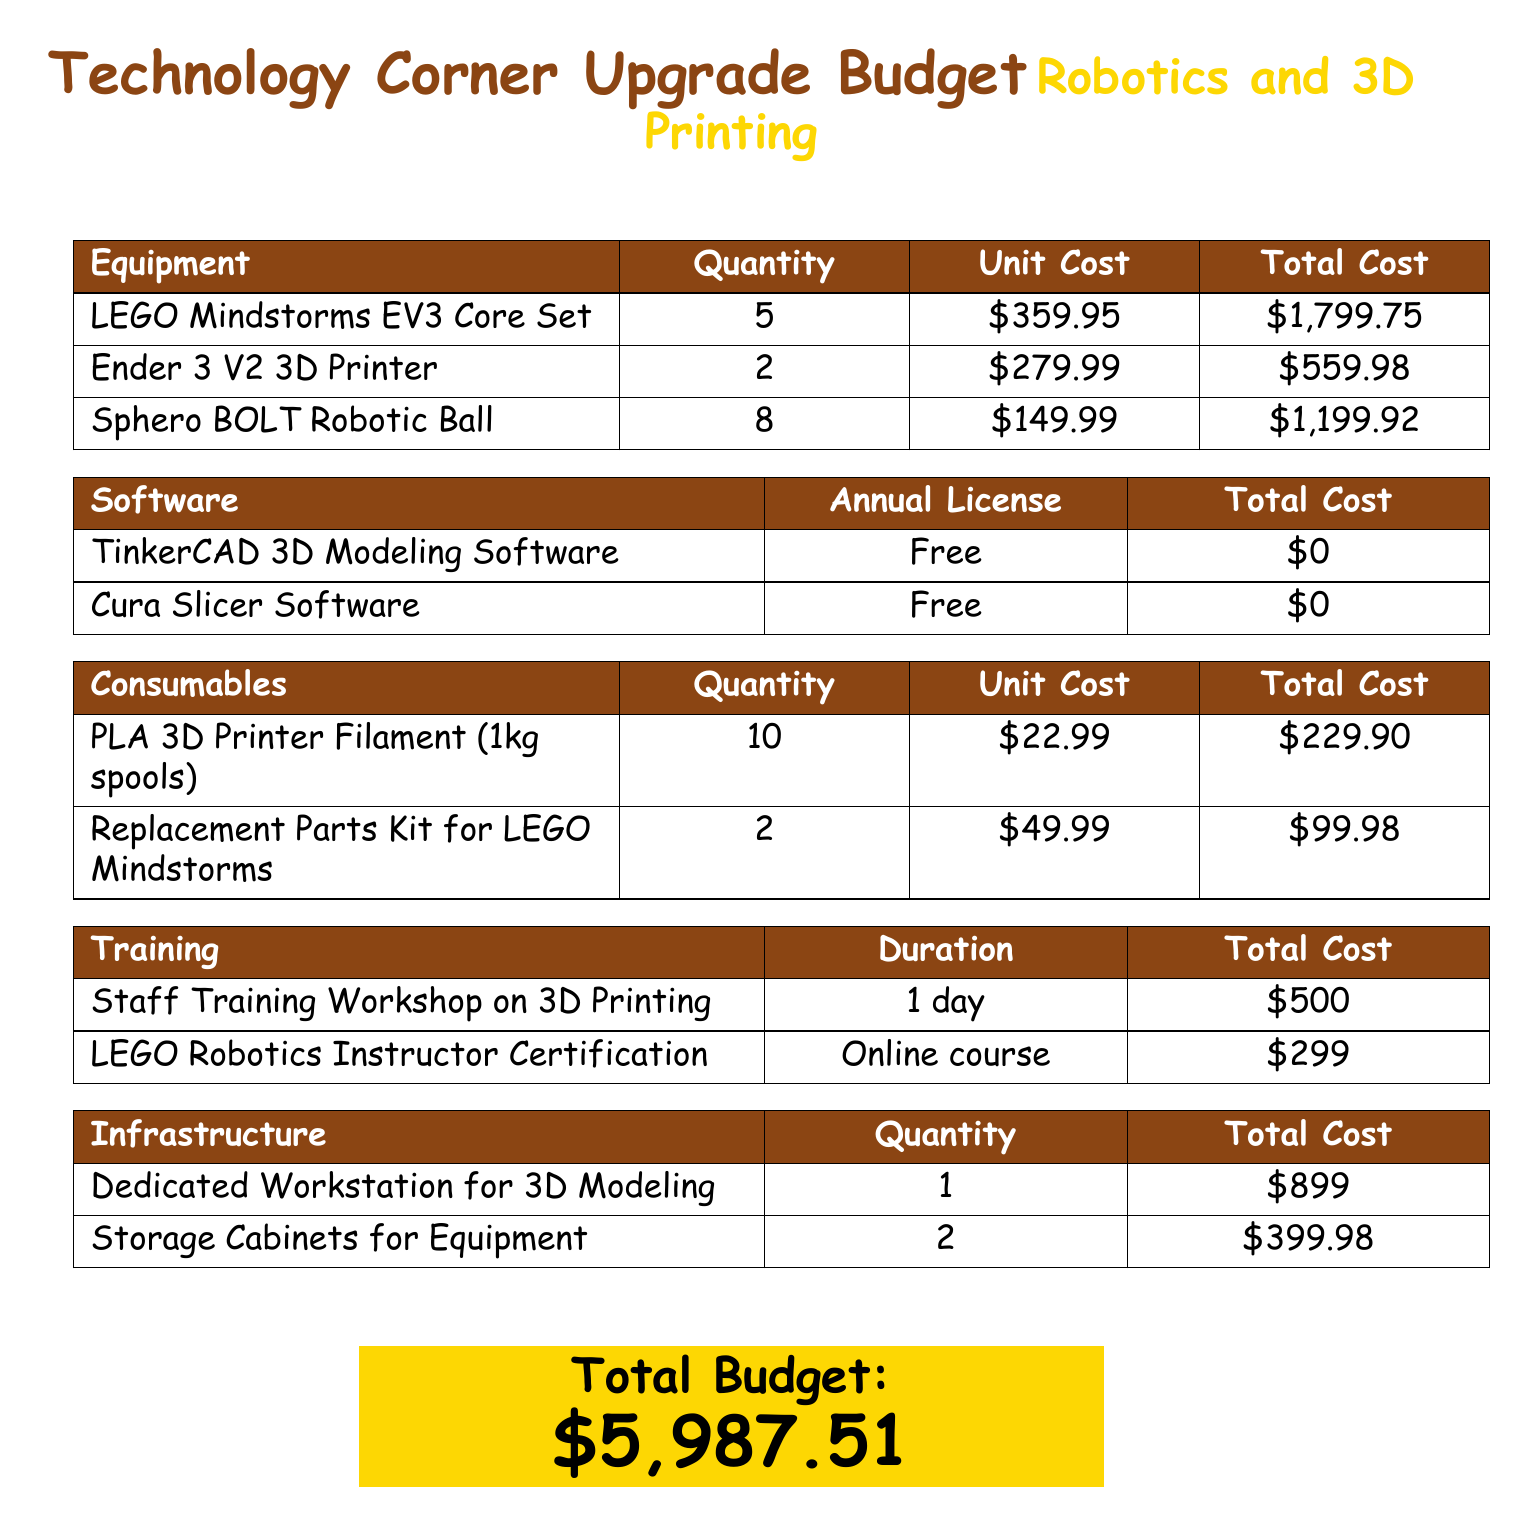What is the total cost of the LEGO Mindstorms EV3 Core Sets? The total cost for the LEGO Mindstorms EV3 Core Sets is calculated by multiplying the quantity (5) by the unit cost (\$359.95), resulting in \$1,799.75.
Answer: \$1,799.75 How many 3D printers are included in the budget? The budget includes 2 3D printers, specifically the Ender 3 V2 3D Printers.
Answer: 2 What is the annual license cost for the TinkerCAD 3D Modeling Software? The document states that the TinkerCAD 3D Modeling Software has a total cost of \$0 since it is free.
Answer: \$0 What is the total budget for the Technology Corner upgrade? The total budget for the Technology Corner upgrade is stated clearly at the end of the document as \$5,987.51.
Answer: \$5,987.51 How much does a single 1kg spool of PLA 3D Printer Filament cost? The cost of a single 1kg spool of PLA 3D Printer Filament is mentioned as \$22.99.
Answer: \$22.99 What is the cost of the LEGO Robotics Instructor Certification? The budget lists the cost of the LEGO Robotics Instructor Certification as \$299.
Answer: \$299 How many Sphero BOLT Robotic Balls are budgeted? The budget specifies that there are 8 Sphero BOLT Robotic Balls included in the upgrade.
Answer: 8 What is the total cost for storage cabinets for equipment? The total cost for the storage cabinets is calculated from the unit cost of \$399.98 for 2 units, but the document provides the total directly as \$399.98.
Answer: \$399.98 What training duration is specified for the Staff Training Workshop on 3D Printing? The duration for the Staff Training Workshop on 3D Printing is specified as 1 day in the document.
Answer: 1 day 